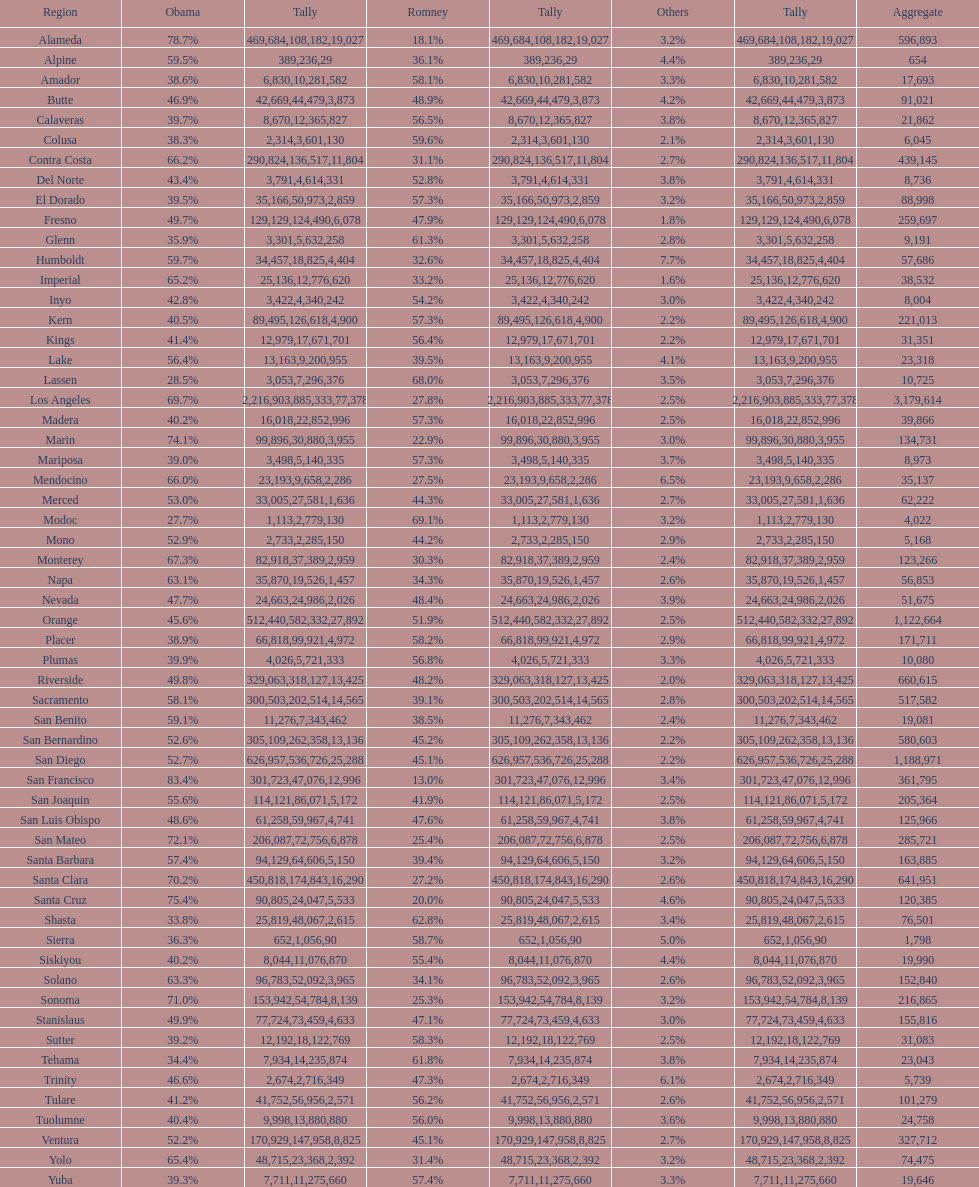What is the total number of votes for amador? 17693. 